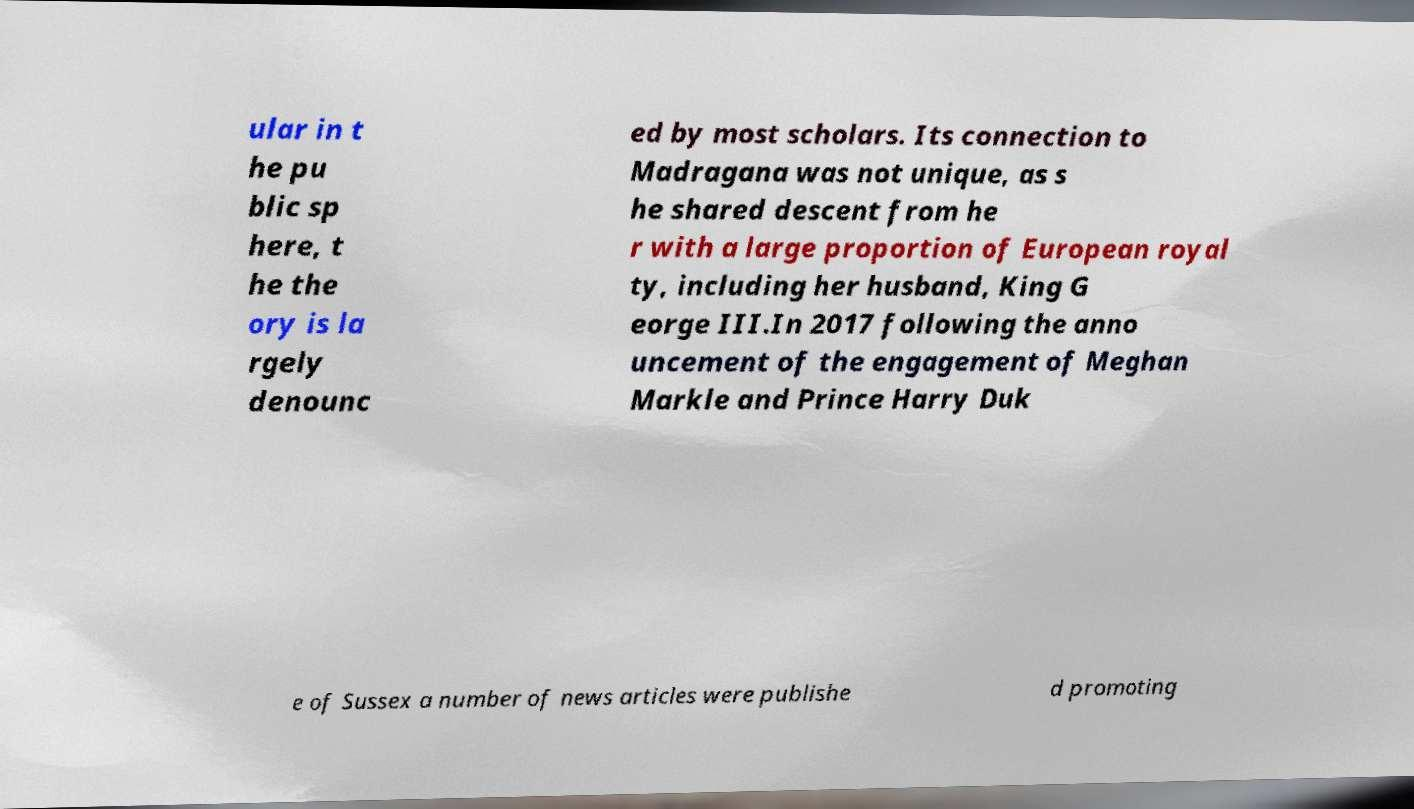Please identify and transcribe the text found in this image. ular in t he pu blic sp here, t he the ory is la rgely denounc ed by most scholars. Its connection to Madragana was not unique, as s he shared descent from he r with a large proportion of European royal ty, including her husband, King G eorge III.In 2017 following the anno uncement of the engagement of Meghan Markle and Prince Harry Duk e of Sussex a number of news articles were publishe d promoting 